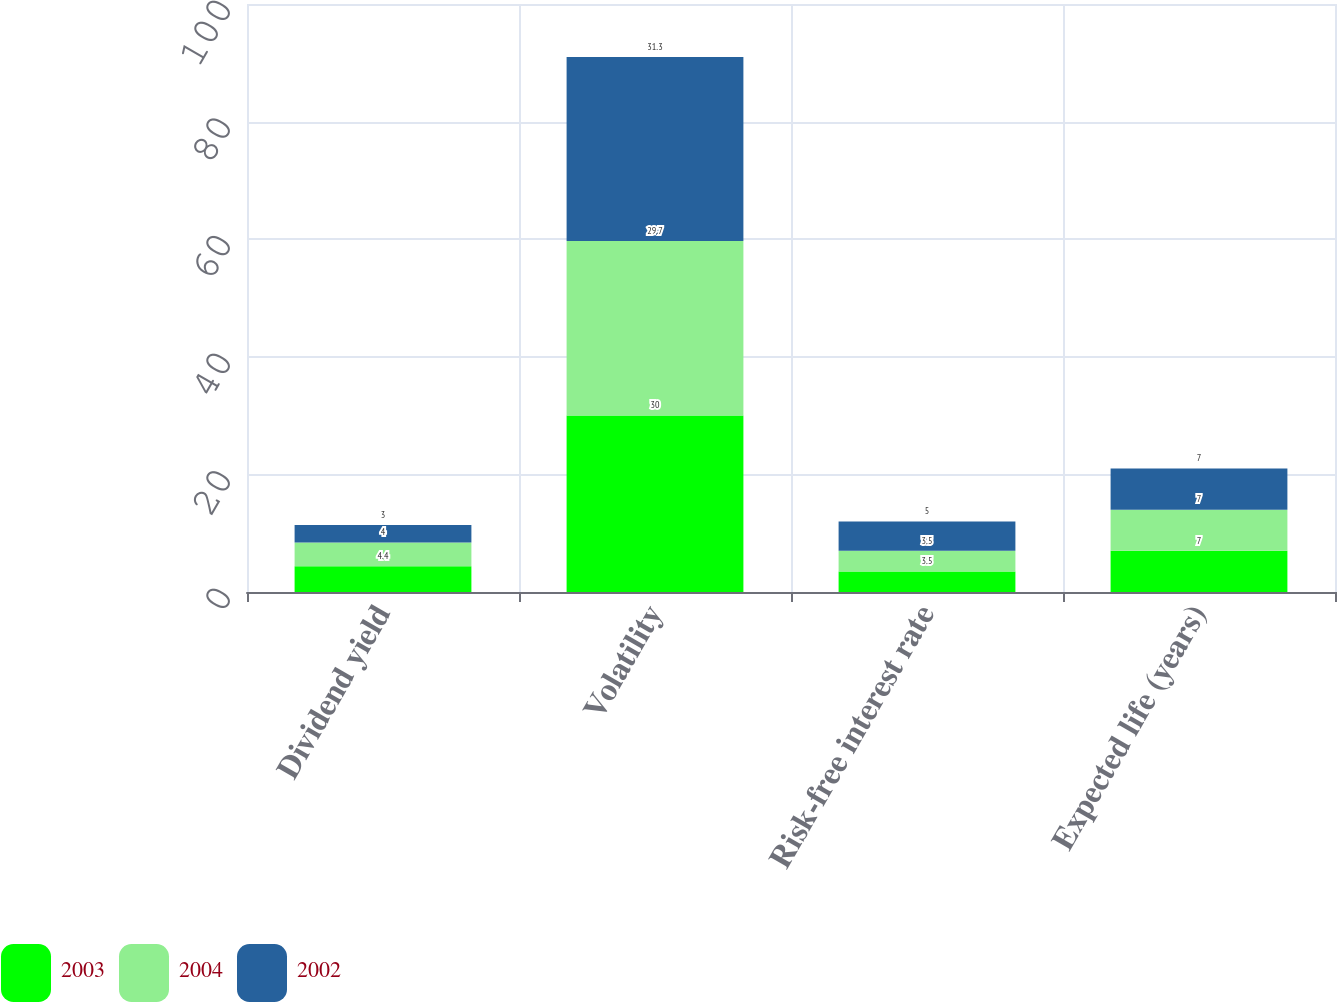<chart> <loc_0><loc_0><loc_500><loc_500><stacked_bar_chart><ecel><fcel>Dividend yield<fcel>Volatility<fcel>Risk-free interest rate<fcel>Expected life (years)<nl><fcel>2003<fcel>4.4<fcel>30<fcel>3.5<fcel>7<nl><fcel>2004<fcel>4<fcel>29.7<fcel>3.5<fcel>7<nl><fcel>2002<fcel>3<fcel>31.3<fcel>5<fcel>7<nl></chart> 